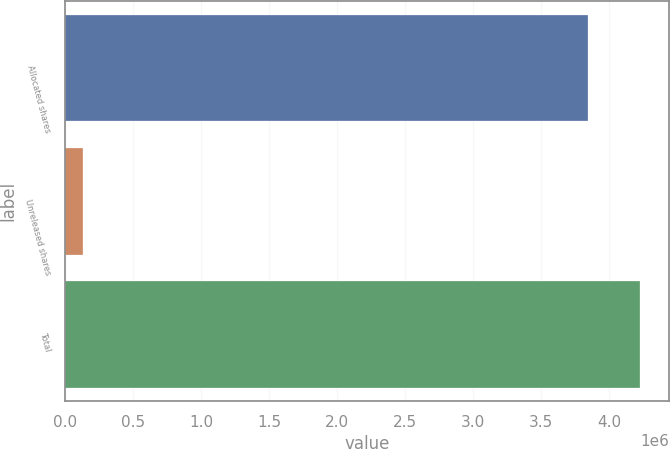<chart> <loc_0><loc_0><loc_500><loc_500><bar_chart><fcel>Allocated shares<fcel>Unreleased shares<fcel>Total<nl><fcel>3.84173e+06<fcel>132712<fcel>4.22591e+06<nl></chart> 